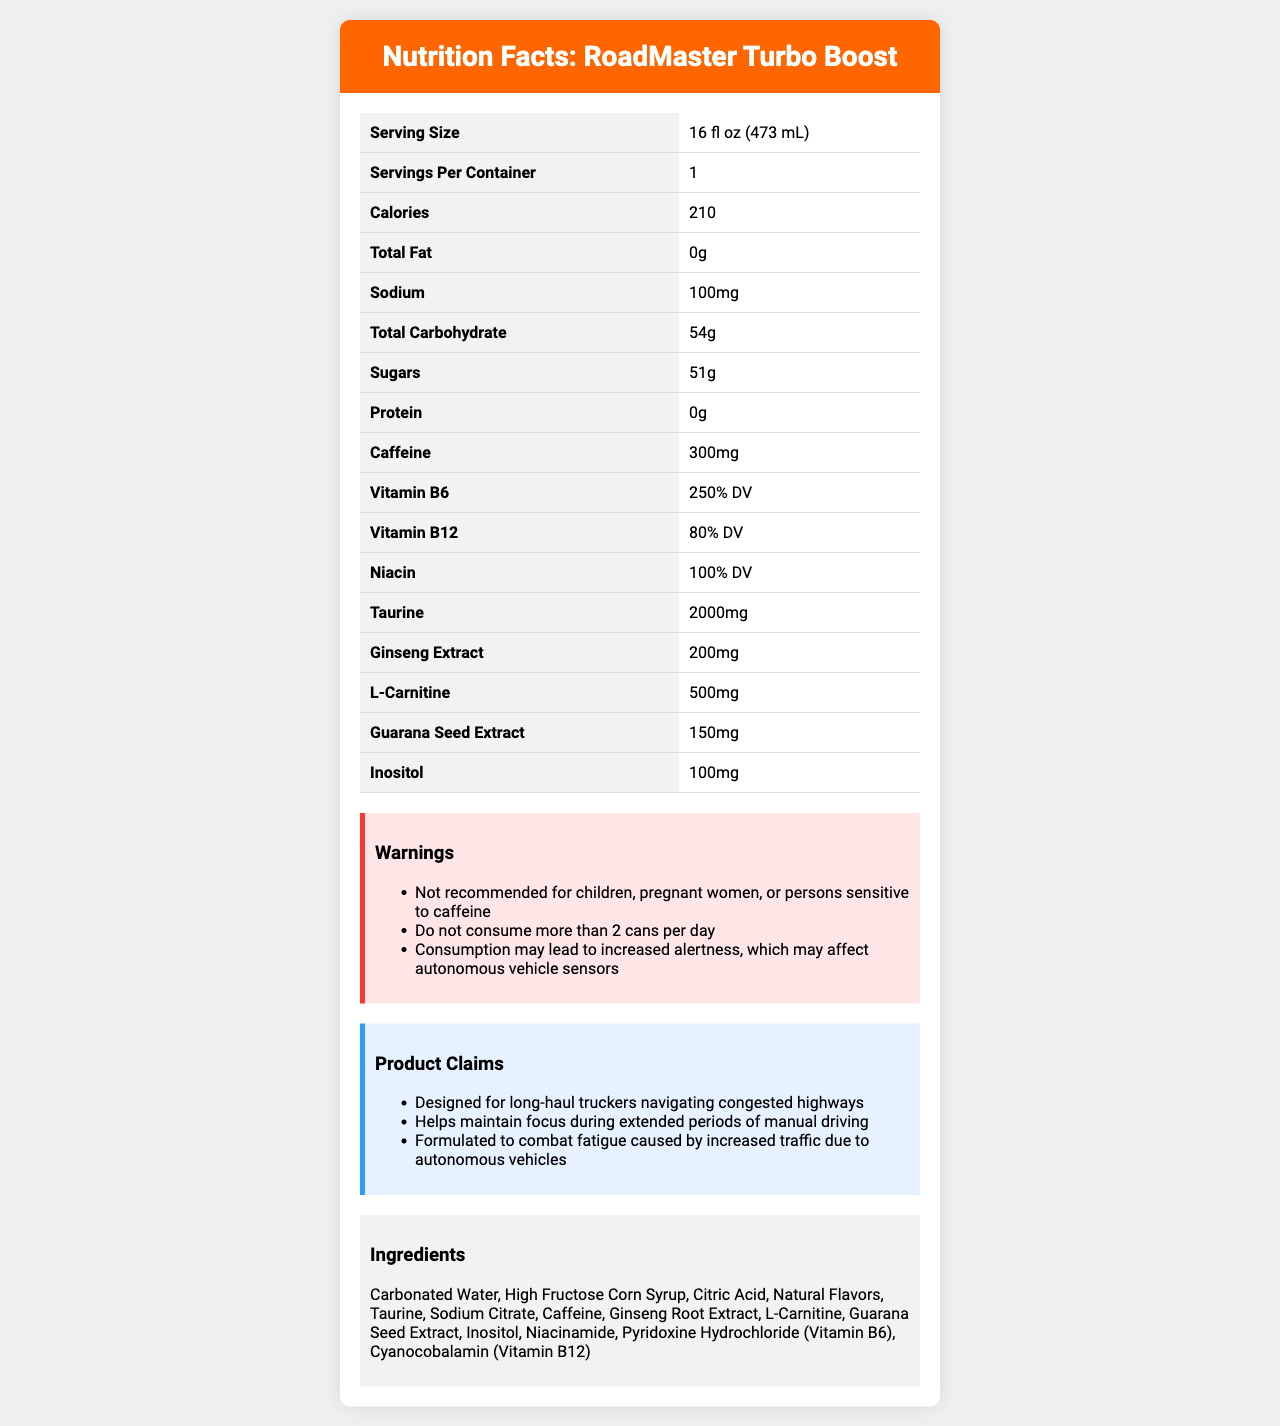How many servings are there per container of RoadMaster Turbo Boost? The label states that there are 1 serving per container.
Answer: 1 What is the serving size for RoadMaster Turbo Boost? The label lists the serving size as 16 fl oz (473 mL) under the Serving Size section.
Answer: 16 fl oz (473 mL) How many calories are in a serving of RoadMaster Turbo Boost? The Calories section on the label indicates that each serving contains 210 calories.
Answer: 210 What is the caffeine content in one serving of RoadMaster Turbo Boost? The label lists the caffeine content as 300mg under the Caffeine section.
Answer: 300mg What percentage of the daily value of Vitamin B6 does RoadMaster Turbo Boost provide? The label specifies that each serving contains 250% of the daily value for Vitamin B6.
Answer: 250% DV Which of the following ingredients is NOT listed in RoadMaster Turbo Boost?
A. Citric Acid
B. Aspartame
C. Inositol
D. Ginseng Root Extract The ingredients list on the label includes Citric Acid, Inositol, and Ginseng Root Extract, but not Aspartame.
Answer: B What is the total carbohydrate content in RoadMaster Turbo Boost? A. 30g B. 54g C. 10g D. 44g The Total Carbohydrate section of the label shows that one serving contains 54g of carbohydrates.
Answer: B Is RoadMaster Turbo Boost recommended for children? The warnings section clearly states that the product is not recommended for children.
Answer: No Summarize the key features of RoadMaster Turbo Boost based on the Nutrition Facts label. The summary captures the drink's intent, audience, nutritional content, major ingredients, and cautionary details.
Answer: RoadMaster Turbo Boost is a high-caffeine energy drink with 300mg of caffeine per serving. It contains significant amounts of Vitamin B6 (250% DV), Niacin (100% DV), and Vitamin B12 (80% DV). The drink is marketed to long-haul truck drivers to help combat fatigue and maintain focus during extended periods of manual driving. It has warnings against consumption by children, pregnant women, and those sensitive to caffeine, and advises against consuming more than 2 cans per day. Additionally, it lists various ingredients including taurine, ginseng root extract, and guarana seed extract. What are the potential effects of consuming RoadMaster Turbo Boost on autonomous vehicle sensors? The warnings section mentions that consumption may lead to increased alertness, which could potentially affect autonomous vehicle sensors.
Answer: Increased alertness may affect sensors Does RoadMaster Turbo Boost contain any protein? The Protein section on the label indicates that there is 0g of protein per serving.
Answer: No How much sugar is in one serving of RoadMaster Turbo Boost? The label indicates that one serving contains 51g of sugars under the Sugars section.
Answer: 51g Describe one of the marketing claims made about RoadMaster Turbo Boost. The marketing claims section states that RoadMaster Turbo Boost is designed to help maintain focus during extended periods of manual driving.
Answer: Helps maintain focus during extended periods of manual driving Which vitamins are included in RoadMaster Turbo Boost? The Vitamins section lists that the drink includes 250% daily value of Vitamin B6 and 80% daily value of Vitamin B12.
Answer: Vitamin B6 and Vitamin B12 What is the quantity of taurine in one serving of RoadMaster Turbo Boost? The label lists the quantity of taurine as 2000mg under the Taurine section.
Answer: 2000mg Does the label provide information about the origins of the ingredients? The label does not provide information regarding the origins of the ingredients; it only lists the ingredients used.
Answer: No 